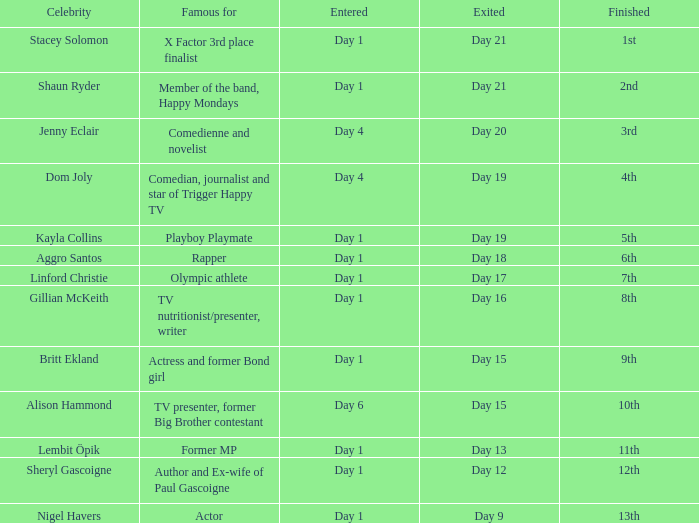What rank did the star attain who participated on day 1 and left on day 19? 5th. 